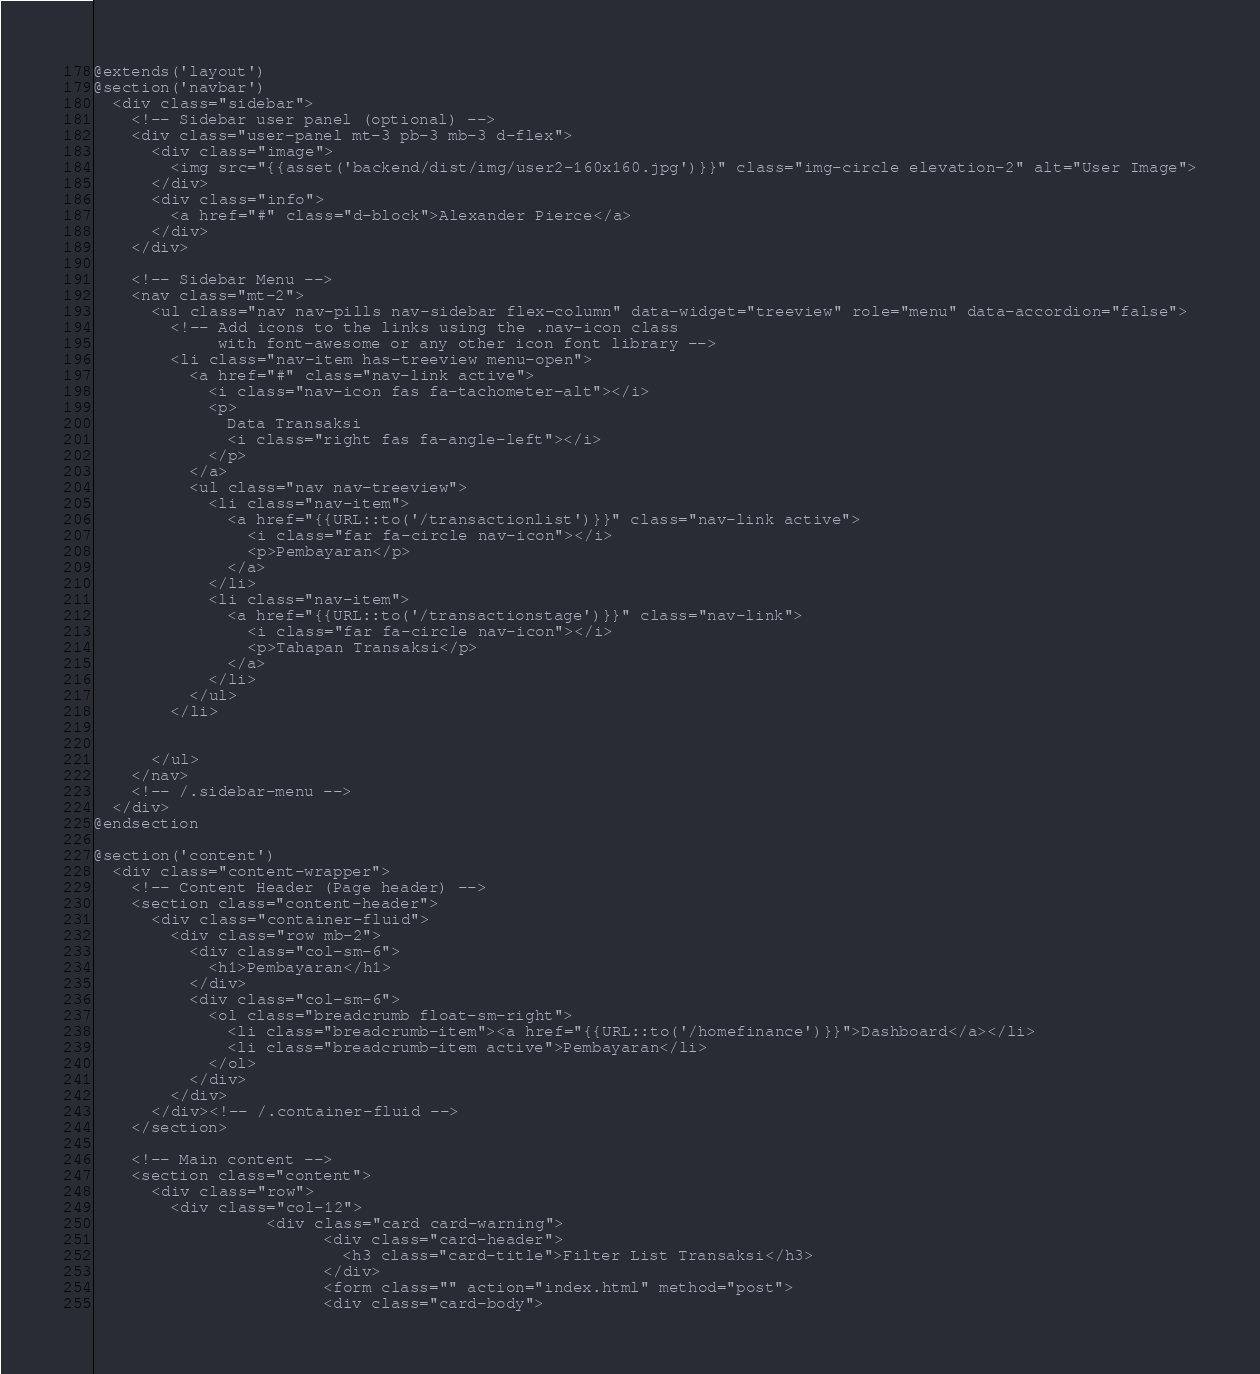Convert code to text. <code><loc_0><loc_0><loc_500><loc_500><_PHP_>@extends('layout')
@section('navbar')
  <div class="sidebar">
    <!-- Sidebar user panel (optional) -->
    <div class="user-panel mt-3 pb-3 mb-3 d-flex">
      <div class="image">
        <img src="{{asset('backend/dist/img/user2-160x160.jpg')}}" class="img-circle elevation-2" alt="User Image">
      </div>
      <div class="info">
        <a href="#" class="d-block">Alexander Pierce</a>
      </div>
    </div>

    <!-- Sidebar Menu -->
    <nav class="mt-2">
      <ul class="nav nav-pills nav-sidebar flex-column" data-widget="treeview" role="menu" data-accordion="false">
        <!-- Add icons to the links using the .nav-icon class
             with font-awesome or any other icon font library -->
        <li class="nav-item has-treeview menu-open">
          <a href="#" class="nav-link active">
            <i class="nav-icon fas fa-tachometer-alt"></i>
            <p>
              Data Transaksi
              <i class="right fas fa-angle-left"></i>
            </p>
          </a>
          <ul class="nav nav-treeview">
            <li class="nav-item">
              <a href="{{URL::to('/transactionlist')}}" class="nav-link active">
                <i class="far fa-circle nav-icon"></i>
                <p>Pembayaran</p>
              </a>
            </li>
            <li class="nav-item">
              <a href="{{URL::to('/transactionstage')}}" class="nav-link">
                <i class="far fa-circle nav-icon"></i>
                <p>Tahapan Transaksi</p>
              </a>
            </li>
          </ul>
        </li>


      </ul>
    </nav>
    <!-- /.sidebar-menu -->
  </div>
@endsection

@section('content')
  <div class="content-wrapper">
    <!-- Content Header (Page header) -->
    <section class="content-header">
      <div class="container-fluid">
        <div class="row mb-2">
          <div class="col-sm-6">
            <h1>Pembayaran</h1>
          </div>
          <div class="col-sm-6">
            <ol class="breadcrumb float-sm-right">
              <li class="breadcrumb-item"><a href="{{URL::to('/homefinance')}}">Dashboard</a></li>
              <li class="breadcrumb-item active">Pembayaran</li>
            </ol>
          </div>
        </div>
      </div><!-- /.container-fluid -->
    </section>

    <!-- Main content -->
    <section class="content">
      <div class="row">
        <div class="col-12">
                  <div class="card card-warning">
                        <div class="card-header">
                          <h3 class="card-title">Filter List Transaksi</h3>
                        </div>
                        <form class="" action="index.html" method="post">
                        <div class="card-body"></code> 